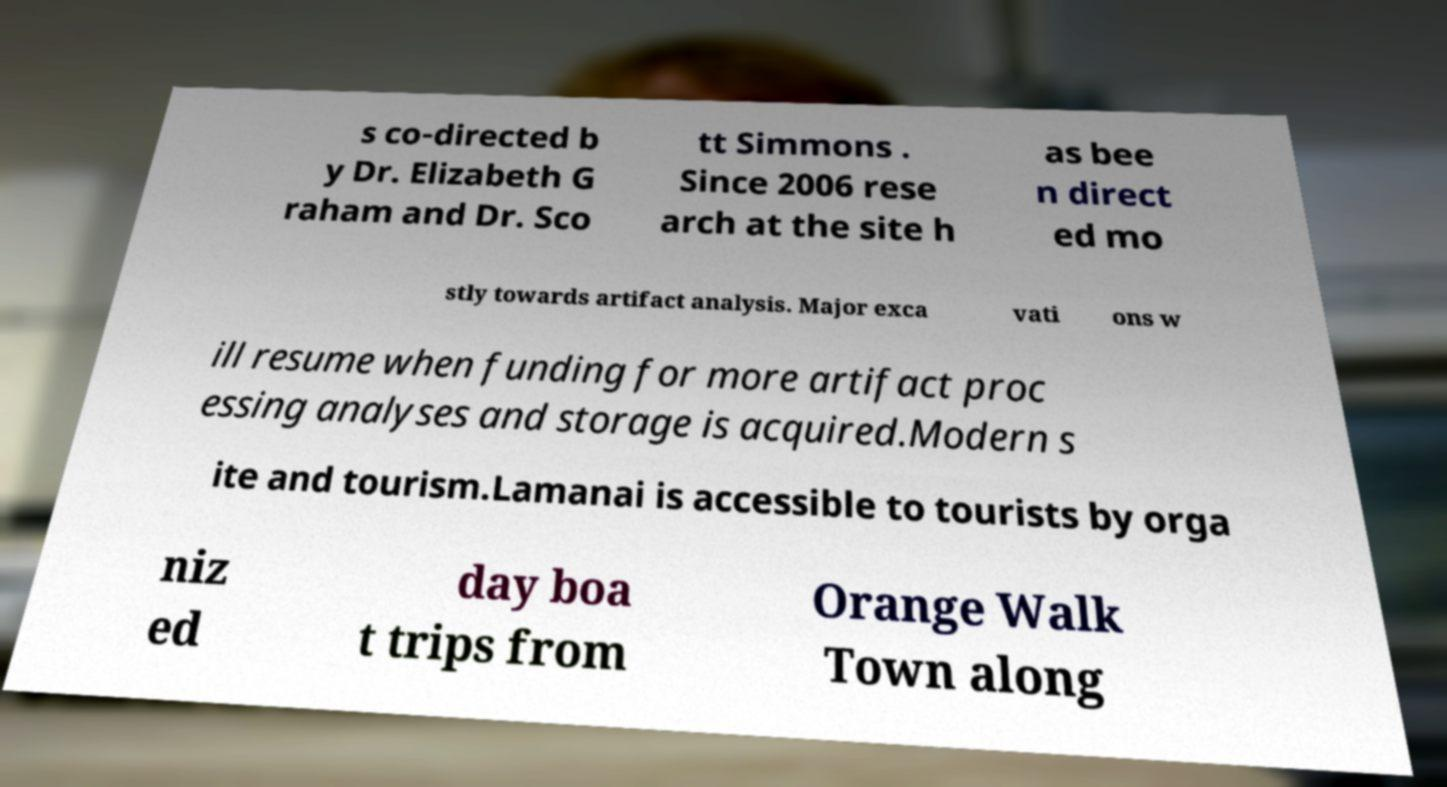Please read and relay the text visible in this image. What does it say? s co-directed b y Dr. Elizabeth G raham and Dr. Sco tt Simmons . Since 2006 rese arch at the site h as bee n direct ed mo stly towards artifact analysis. Major exca vati ons w ill resume when funding for more artifact proc essing analyses and storage is acquired.Modern s ite and tourism.Lamanai is accessible to tourists by orga niz ed day boa t trips from Orange Walk Town along 